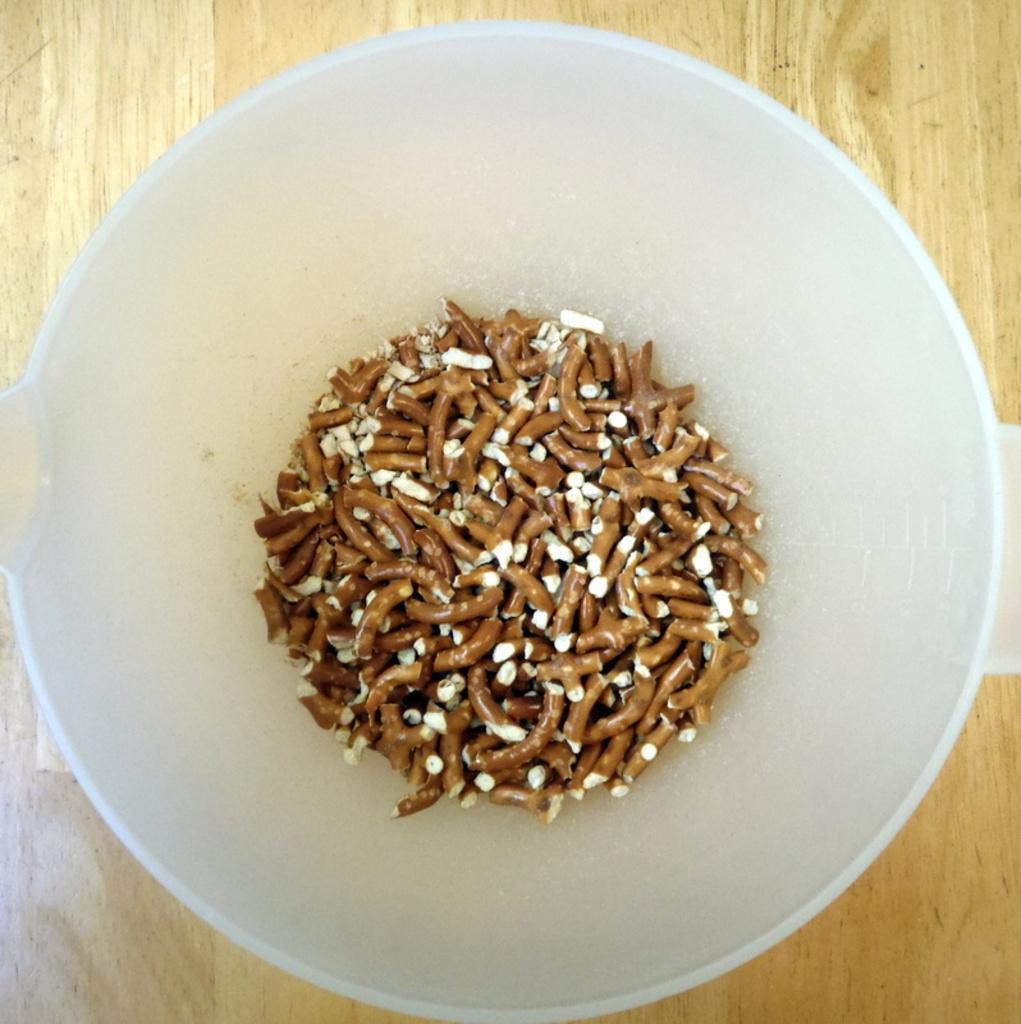Can you describe this image briefly? In this image in the center there is one bowl and in the bowl there are some food items, and in the background there is a wooden board. 